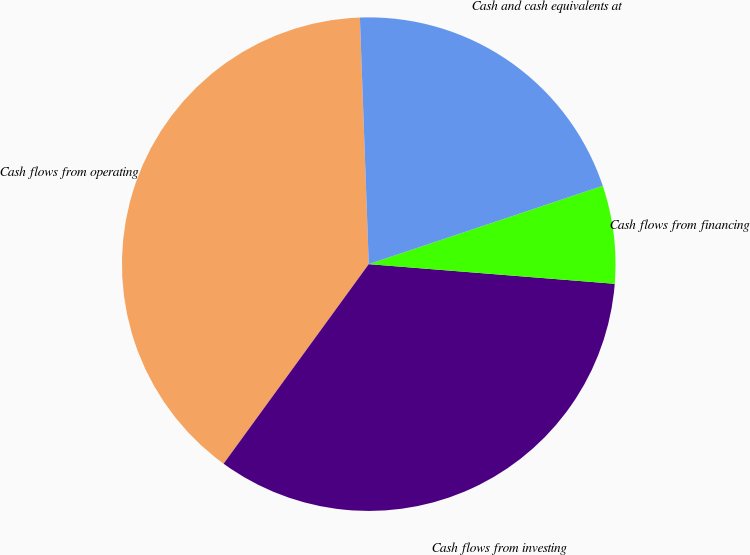<chart> <loc_0><loc_0><loc_500><loc_500><pie_chart><fcel>Cash flows from operating<fcel>Cash flows from investing<fcel>Cash flows from financing<fcel>Cash and cash equivalents at<nl><fcel>39.42%<fcel>33.74%<fcel>6.41%<fcel>20.43%<nl></chart> 